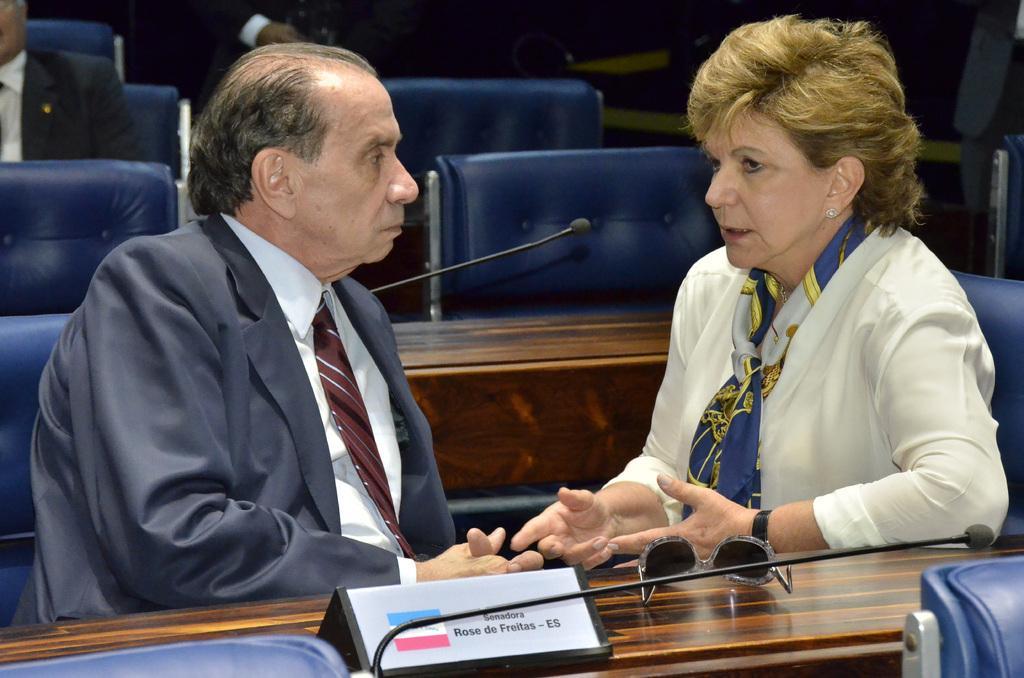Describe this image in one or two sentences. In this picture, we see a man in the blue blazer and a woman are sitting on the chairs. Both of them are talking to each other. In front of them, we see a table on which a microphone, goggles and a name board are placed. Behind them, we see the empty chairs. In the background, we see two men are sitting on the chairs. On the right side, we see a table. In the background, it is black in color. 